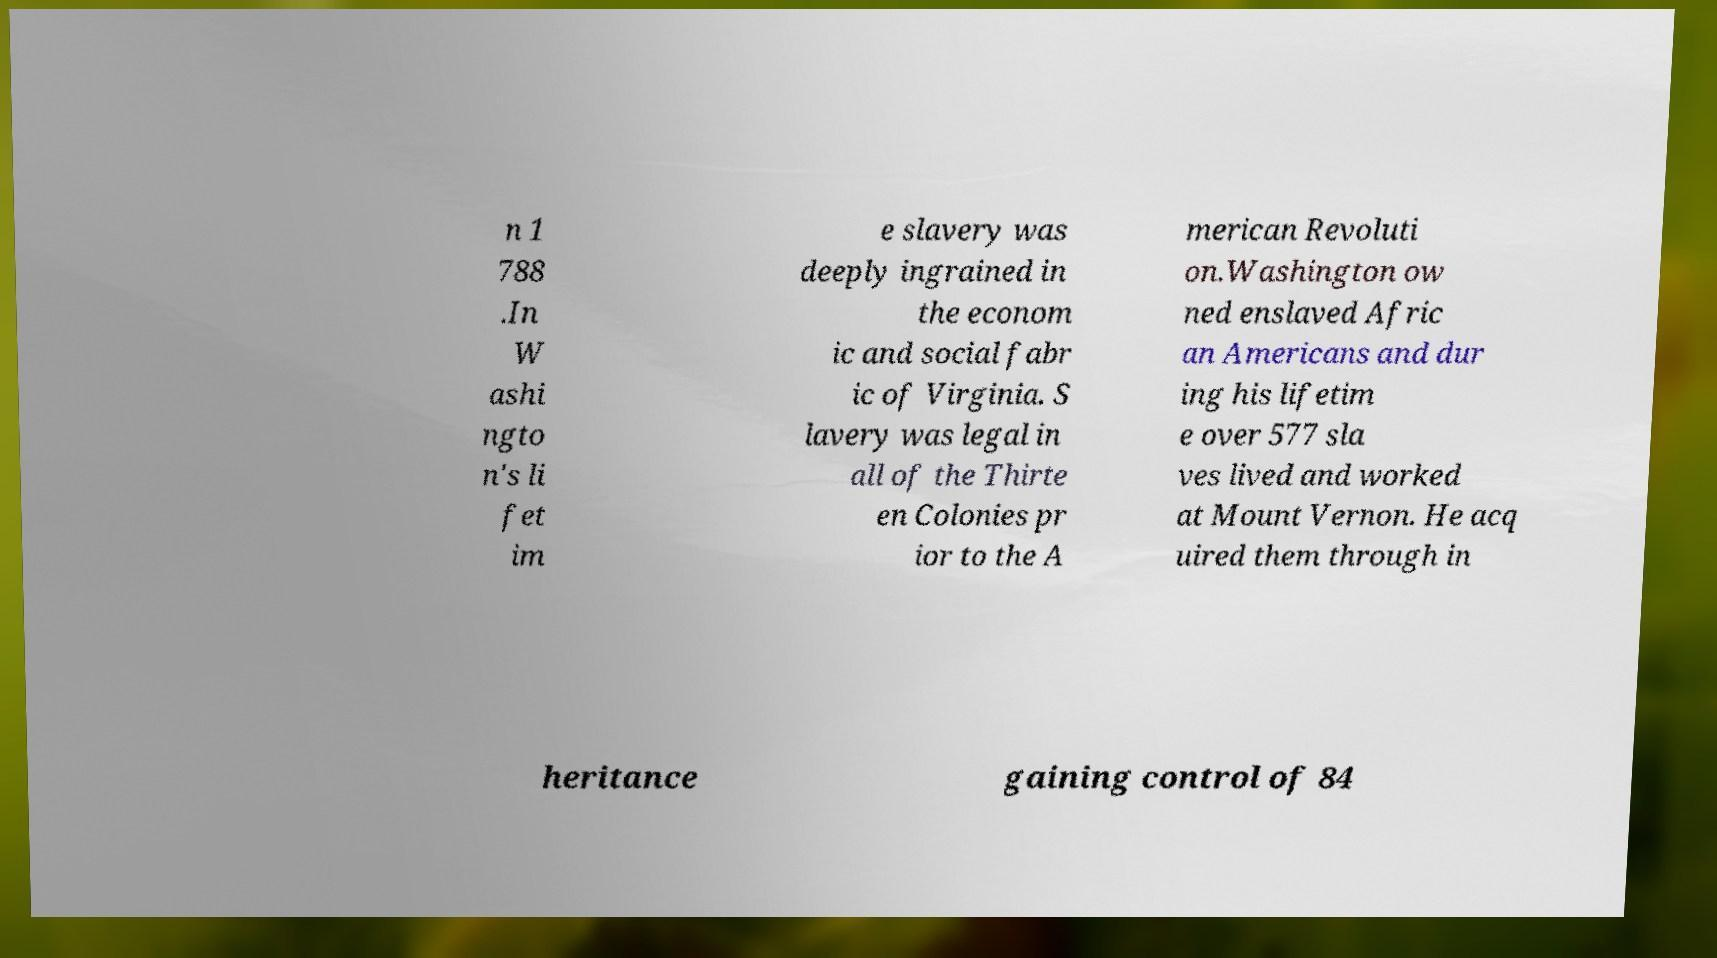There's text embedded in this image that I need extracted. Can you transcribe it verbatim? n 1 788 .In W ashi ngto n's li fet im e slavery was deeply ingrained in the econom ic and social fabr ic of Virginia. S lavery was legal in all of the Thirte en Colonies pr ior to the A merican Revoluti on.Washington ow ned enslaved Afric an Americans and dur ing his lifetim e over 577 sla ves lived and worked at Mount Vernon. He acq uired them through in heritance gaining control of 84 